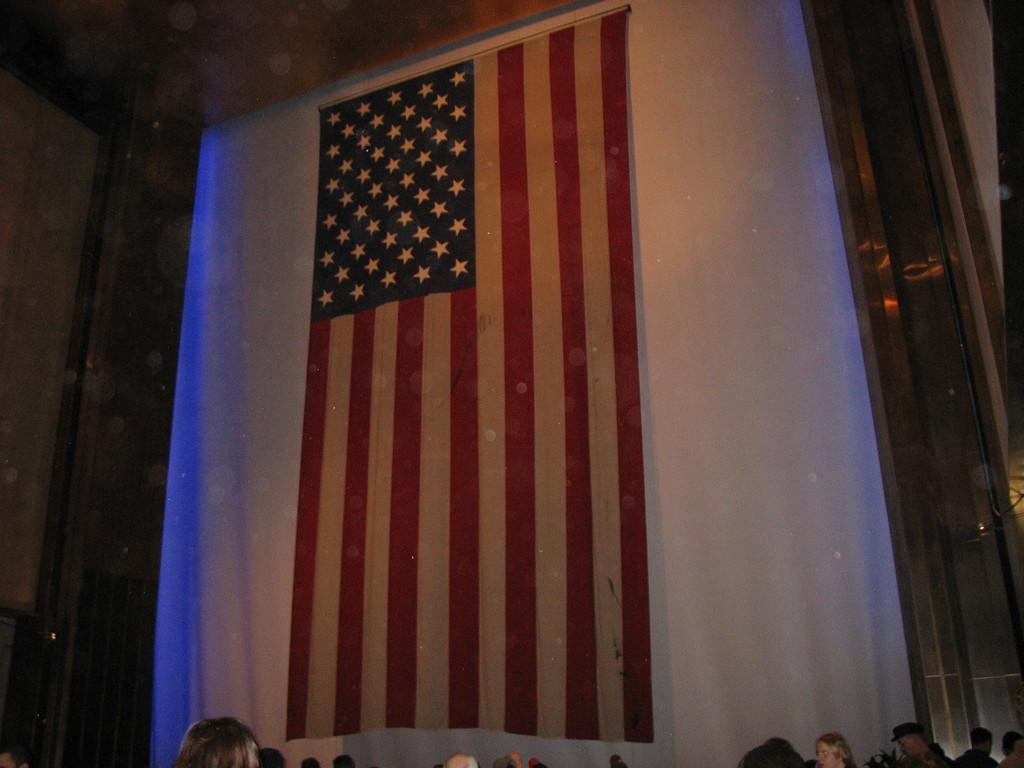Describe this image in one or two sentences. In this image there are persons and there is a flag. 